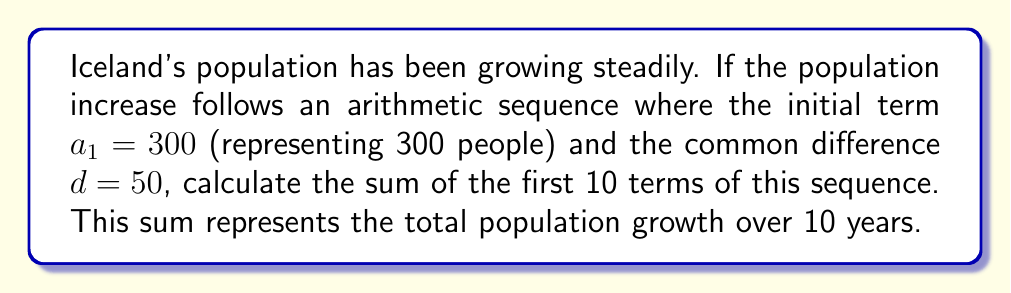Can you solve this math problem? Let's approach this step-by-step:

1) We're dealing with an arithmetic sequence where:
   $a_1 = 300$ (initial term)
   $d = 50$ (common difference)
   $n = 10$ (number of terms)

2) The formula for the sum of an arithmetic sequence is:

   $$S_n = \frac{n}{2}(a_1 + a_n)$$

   where $a_n$ is the last term of the sequence.

3) To find $a_n$, we use the formula:

   $$a_n = a_1 + (n-1)d$$

4) Substituting our values:

   $$a_{10} = 300 + (10-1)50 = 300 + 450 = 750$$

5) Now we can use the sum formula:

   $$S_{10} = \frac{10}{2}(300 + 750)$$

6) Simplifying:

   $$S_{10} = 5(1050) = 5250$$

Therefore, the sum of the first 10 terms is 5250.
Answer: 5250 